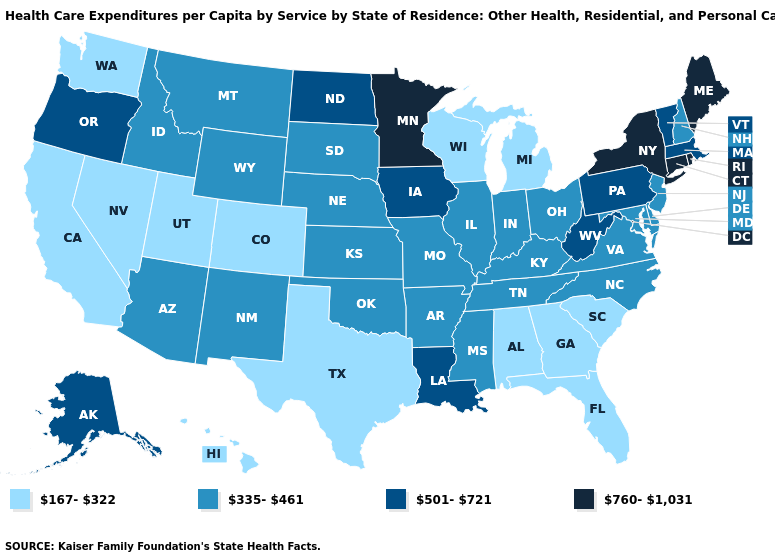What is the value of Iowa?
Keep it brief. 501-721. Is the legend a continuous bar?
Give a very brief answer. No. Among the states that border New York , does Vermont have the highest value?
Short answer required. No. What is the value of Arkansas?
Be succinct. 335-461. Name the states that have a value in the range 335-461?
Short answer required. Arizona, Arkansas, Delaware, Idaho, Illinois, Indiana, Kansas, Kentucky, Maryland, Mississippi, Missouri, Montana, Nebraska, New Hampshire, New Jersey, New Mexico, North Carolina, Ohio, Oklahoma, South Dakota, Tennessee, Virginia, Wyoming. What is the highest value in states that border Illinois?
Short answer required. 501-721. Name the states that have a value in the range 335-461?
Answer briefly. Arizona, Arkansas, Delaware, Idaho, Illinois, Indiana, Kansas, Kentucky, Maryland, Mississippi, Missouri, Montana, Nebraska, New Hampshire, New Jersey, New Mexico, North Carolina, Ohio, Oklahoma, South Dakota, Tennessee, Virginia, Wyoming. Does Iowa have the same value as North Dakota?
Concise answer only. Yes. Does Texas have the same value as North Dakota?
Concise answer only. No. Among the states that border Wisconsin , does Michigan have the lowest value?
Keep it brief. Yes. Does North Carolina have the highest value in the USA?
Quick response, please. No. Name the states that have a value in the range 760-1,031?
Answer briefly. Connecticut, Maine, Minnesota, New York, Rhode Island. Name the states that have a value in the range 335-461?
Give a very brief answer. Arizona, Arkansas, Delaware, Idaho, Illinois, Indiana, Kansas, Kentucky, Maryland, Mississippi, Missouri, Montana, Nebraska, New Hampshire, New Jersey, New Mexico, North Carolina, Ohio, Oklahoma, South Dakota, Tennessee, Virginia, Wyoming. What is the lowest value in the USA?
Concise answer only. 167-322. Name the states that have a value in the range 501-721?
Give a very brief answer. Alaska, Iowa, Louisiana, Massachusetts, North Dakota, Oregon, Pennsylvania, Vermont, West Virginia. 